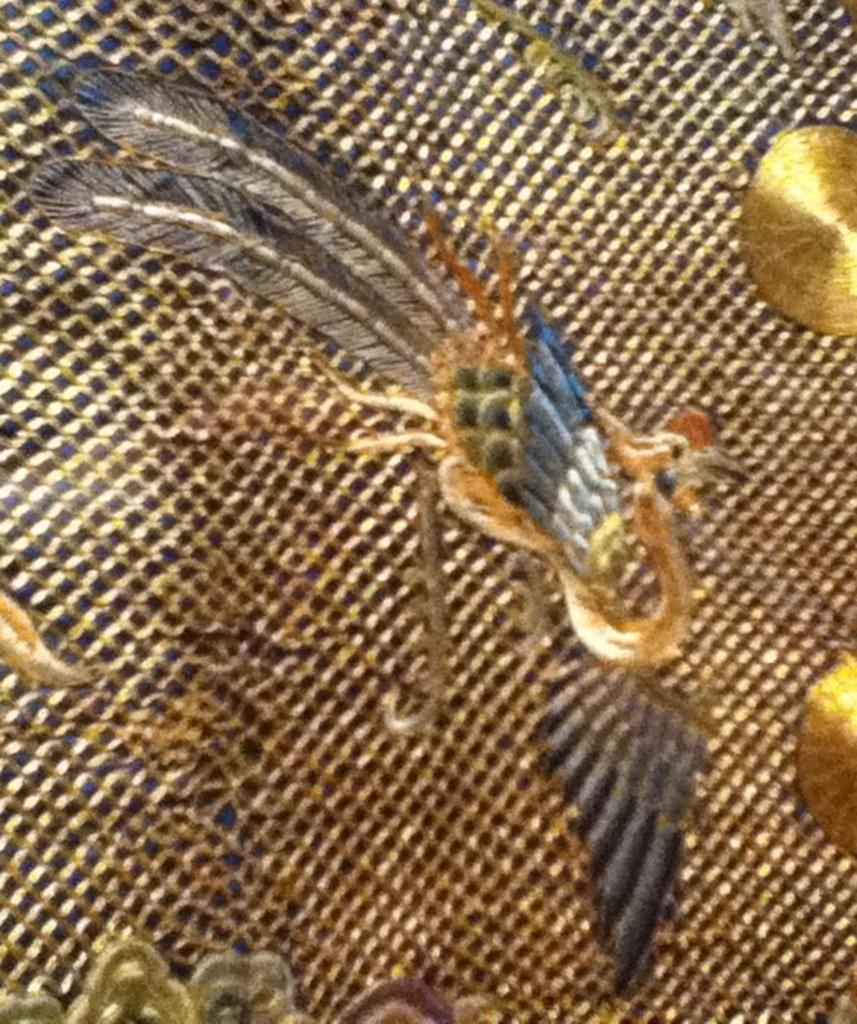How would you summarize this image in a sentence or two? In this image there is some art to the metal body. 